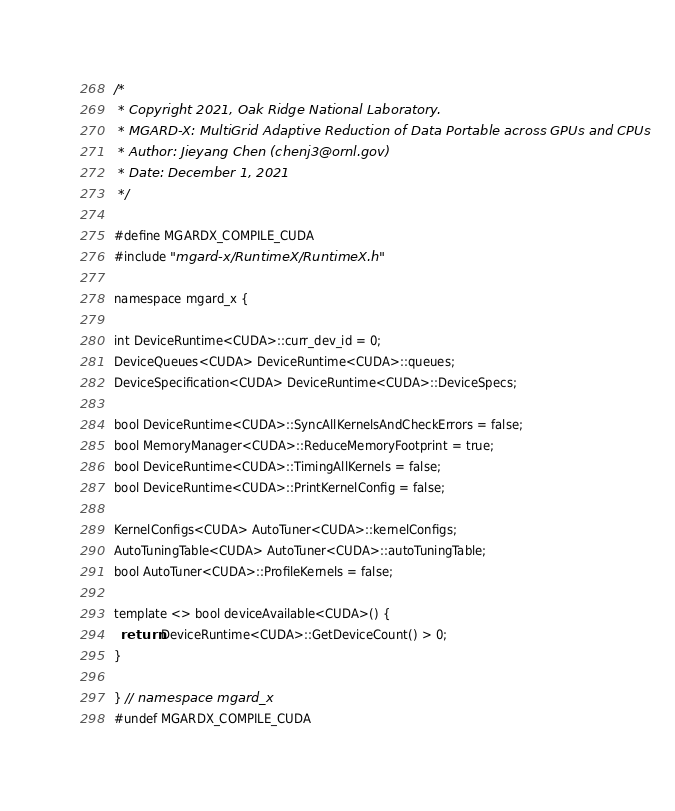Convert code to text. <code><loc_0><loc_0><loc_500><loc_500><_Cuda_>/*
 * Copyright 2021, Oak Ridge National Laboratory.
 * MGARD-X: MultiGrid Adaptive Reduction of Data Portable across GPUs and CPUs
 * Author: Jieyang Chen (chenj3@ornl.gov)
 * Date: December 1, 2021
 */

#define MGARDX_COMPILE_CUDA
#include "mgard-x/RuntimeX/RuntimeX.h"

namespace mgard_x {

int DeviceRuntime<CUDA>::curr_dev_id = 0;
DeviceQueues<CUDA> DeviceRuntime<CUDA>::queues;
DeviceSpecification<CUDA> DeviceRuntime<CUDA>::DeviceSpecs;

bool DeviceRuntime<CUDA>::SyncAllKernelsAndCheckErrors = false;
bool MemoryManager<CUDA>::ReduceMemoryFootprint = true;
bool DeviceRuntime<CUDA>::TimingAllKernels = false;
bool DeviceRuntime<CUDA>::PrintKernelConfig = false;

KernelConfigs<CUDA> AutoTuner<CUDA>::kernelConfigs;
AutoTuningTable<CUDA> AutoTuner<CUDA>::autoTuningTable;
bool AutoTuner<CUDA>::ProfileKernels = false;

template <> bool deviceAvailable<CUDA>() {
  return DeviceRuntime<CUDA>::GetDeviceCount() > 0;
}

} // namespace mgard_x
#undef MGARDX_COMPILE_CUDA</code> 